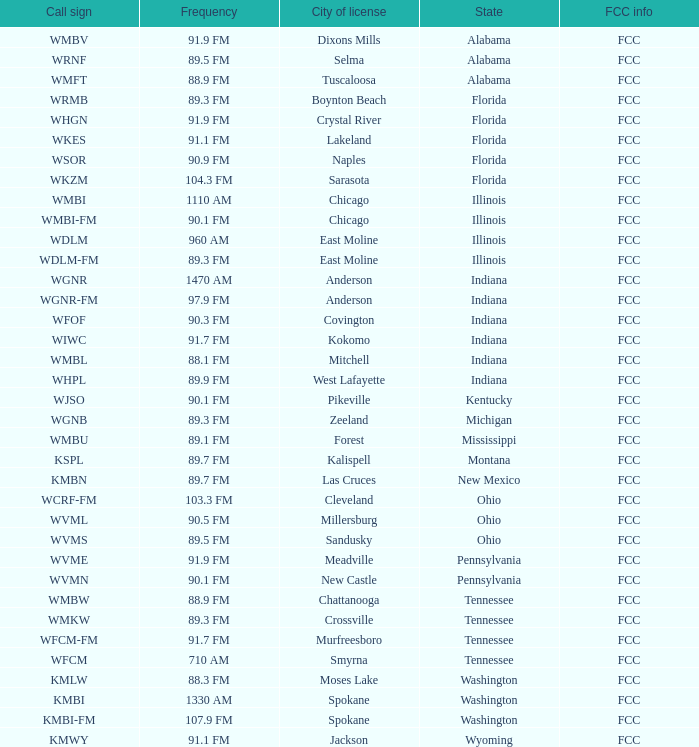What is the FCC info for the radio station in West Lafayette, Indiana? FCC. Can you parse all the data within this table? {'header': ['Call sign', 'Frequency', 'City of license', 'State', 'FCC info'], 'rows': [['WMBV', '91.9 FM', 'Dixons Mills', 'Alabama', 'FCC'], ['WRNF', '89.5 FM', 'Selma', 'Alabama', 'FCC'], ['WMFT', '88.9 FM', 'Tuscaloosa', 'Alabama', 'FCC'], ['WRMB', '89.3 FM', 'Boynton Beach', 'Florida', 'FCC'], ['WHGN', '91.9 FM', 'Crystal River', 'Florida', 'FCC'], ['WKES', '91.1 FM', 'Lakeland', 'Florida', 'FCC'], ['WSOR', '90.9 FM', 'Naples', 'Florida', 'FCC'], ['WKZM', '104.3 FM', 'Sarasota', 'Florida', 'FCC'], ['WMBI', '1110 AM', 'Chicago', 'Illinois', 'FCC'], ['WMBI-FM', '90.1 FM', 'Chicago', 'Illinois', 'FCC'], ['WDLM', '960 AM', 'East Moline', 'Illinois', 'FCC'], ['WDLM-FM', '89.3 FM', 'East Moline', 'Illinois', 'FCC'], ['WGNR', '1470 AM', 'Anderson', 'Indiana', 'FCC'], ['WGNR-FM', '97.9 FM', 'Anderson', 'Indiana', 'FCC'], ['WFOF', '90.3 FM', 'Covington', 'Indiana', 'FCC'], ['WIWC', '91.7 FM', 'Kokomo', 'Indiana', 'FCC'], ['WMBL', '88.1 FM', 'Mitchell', 'Indiana', 'FCC'], ['WHPL', '89.9 FM', 'West Lafayette', 'Indiana', 'FCC'], ['WJSO', '90.1 FM', 'Pikeville', 'Kentucky', 'FCC'], ['WGNB', '89.3 FM', 'Zeeland', 'Michigan', 'FCC'], ['WMBU', '89.1 FM', 'Forest', 'Mississippi', 'FCC'], ['KSPL', '89.7 FM', 'Kalispell', 'Montana', 'FCC'], ['KMBN', '89.7 FM', 'Las Cruces', 'New Mexico', 'FCC'], ['WCRF-FM', '103.3 FM', 'Cleveland', 'Ohio', 'FCC'], ['WVML', '90.5 FM', 'Millersburg', 'Ohio', 'FCC'], ['WVMS', '89.5 FM', 'Sandusky', 'Ohio', 'FCC'], ['WVME', '91.9 FM', 'Meadville', 'Pennsylvania', 'FCC'], ['WVMN', '90.1 FM', 'New Castle', 'Pennsylvania', 'FCC'], ['WMBW', '88.9 FM', 'Chattanooga', 'Tennessee', 'FCC'], ['WMKW', '89.3 FM', 'Crossville', 'Tennessee', 'FCC'], ['WFCM-FM', '91.7 FM', 'Murfreesboro', 'Tennessee', 'FCC'], ['WFCM', '710 AM', 'Smyrna', 'Tennessee', 'FCC'], ['KMLW', '88.3 FM', 'Moses Lake', 'Washington', 'FCC'], ['KMBI', '1330 AM', 'Spokane', 'Washington', 'FCC'], ['KMBI-FM', '107.9 FM', 'Spokane', 'Washington', 'FCC'], ['KMWY', '91.1 FM', 'Jackson', 'Wyoming', 'FCC']]} 